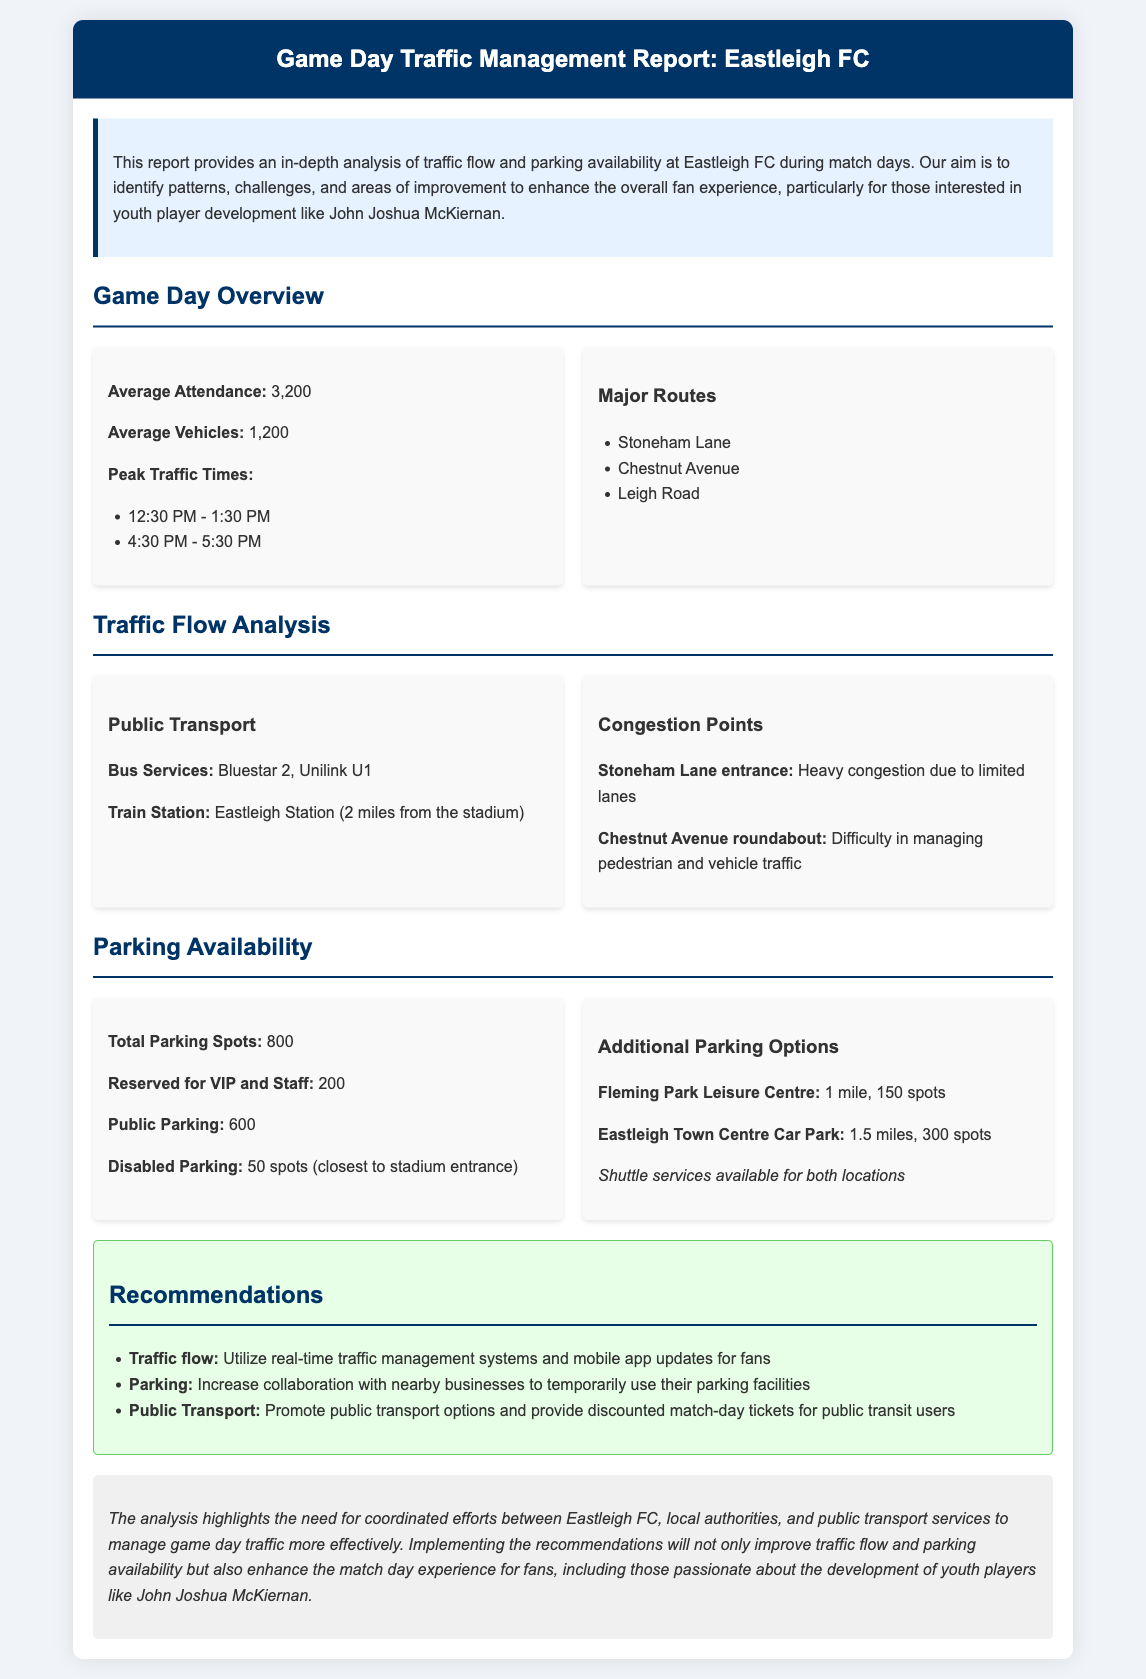What is the average attendance for match days? The average attendance is mentioned as 3,200 in the document.
Answer: 3,200 What time frame is identified as peak traffic times? The document specifies two peak traffic times: 12:30 PM - 1:30 PM and 4:30 PM - 5:30 PM.
Answer: 12:30 PM - 1:30 PM and 4:30 PM - 5:30 PM How many total parking spots are available? The total number of parking spots provided in the document is 800.
Answer: 800 What are the two main bus services mentioned? The document lists Bluestar 2 and Unilink U1 as major bus services.
Answer: Bluestar 2, Unilink U1 What is the distance to the nearest train station from the stadium? The document states that Eastleigh Station is 2 miles from the stadium.
Answer: 2 miles What is one of the congestion points mentioned in the report? The report identifies the Stoneham Lane entrance as a congestion point due to heavy congestion.
Answer: Stoneham Lane entrance What are the recommendations regarding public transport? The document suggests promoting public transport options and providing discounted match-day tickets for public transit users.
Answer: Promote public transport options How many spots are reserved for disabled parking? The document explicitly states that there are 50 spots reserved for disabled parking.
Answer: 50 spots 